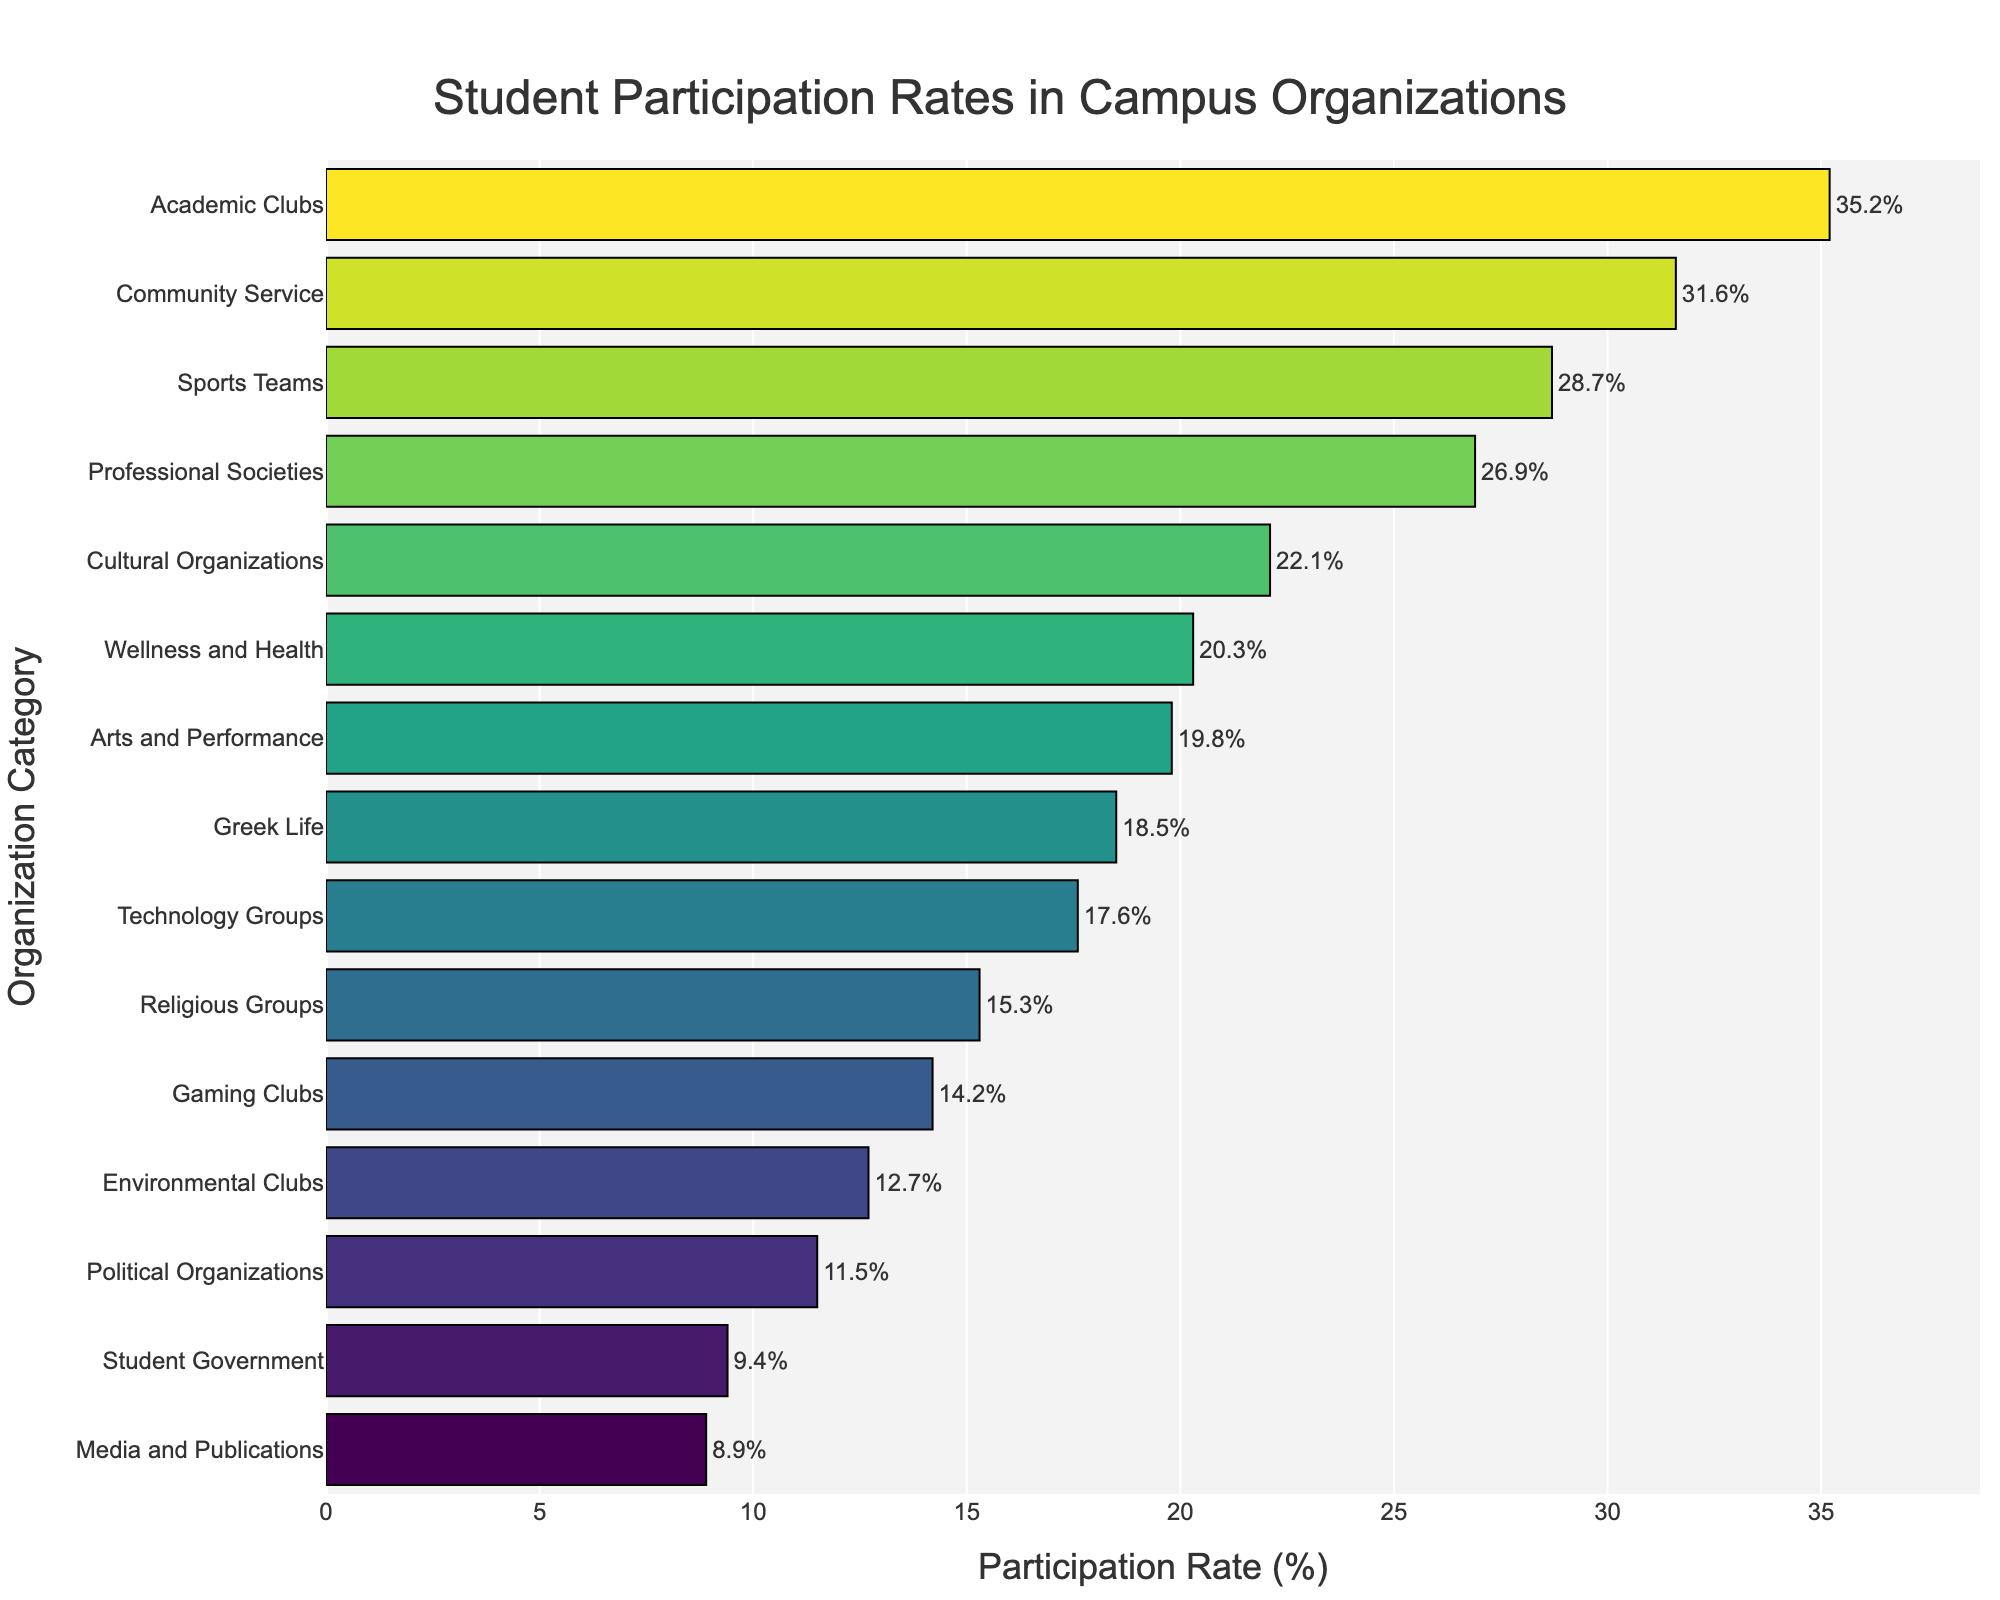Which category has the highest student participation rate? To find the category with the highest participation rate, we look for the longest bar in the chart. The "Academic Clubs" bar is the longest.
Answer: Academic Clubs Which category has the lowest student participation rate? To determine the category with the lowest participation rate, we look for the shortest bar in the chart. The "Media and Publications" bar is the shortest.
Answer: Media and Publications What are the participation rates for Community Service and Wellness and Health combined? First, find the participation rates for Community Service (31.6) and Wellness and Health (20.3). Add them together: 31.6 + 20.3 = 51.9.
Answer: 51.9% Which category has a higher participation rate: Sports Teams or Greek Life? Compare the lengths of the bars for Sports Teams and Greek Life. Sports Teams has a participation rate of 28.7, whereas Greek Life has a rate of 18.5.
Answer: Sports Teams What is the difference in participation rates between Professional Societies and Environmental Clubs? Find the participation rates for Professional Societies (26.9) and Environmental Clubs (12.7). Subtract the smaller rate from the larger: 26.9 - 12.7 = 14.2.
Answer: 14.2% Which categories have participation rates greater than 20%? Locate bars that extend beyond the 20% mark: Academic Clubs, Sports Teams, Community Service, Wellness and Health, and Arts and Performance.
Answer: Academic Clubs, Sports Teams, Community Service, Wellness and Health, Arts and Performance What is the average participation rate of the categories with rates over 25%? Find categories over 25%: Academic Clubs (35.2), Sports Teams (28.7), Community Service (31.6), and Professional Societies (26.9). Calculate the average: (35.2 + 28.7 + 31.6 + 26.9) / 4 = 30.6.
Answer: 30.6% Are there more categories with participation rates above or below 15%? Count categories above 15%: Academic Clubs, Sports Teams, Cultural Organizations, Greek Life, Community Service, Arts and Performance, Professional Societies, Technology Groups, Wellness and Health (9). Count categories below 15%: Political Organizations, Media and Publications, Gaming Clubs, Environmental Clubs, Religious Groups, Student Government, Technology Groups (6).
Answer: Above 15% What is the median participation rate of all categories? Sort the participation rates and find the middle value(s): 8.9, 9.4, 11.5, 12.7, 14.2, 15.3, 17.6, 18.5, 19.8, 20.3, 22.1, 26.9, 28.7, 31.6, 35.2. The median is the middle number: 18.5.
Answer: 18.5% Which category's participation rate is closest to the average rate across all categories? Calculate the total of all participation rates: 35.2 + 28.7 + 22.1 + 18.5 + 31.6 + 9.4 + 19.8 + 15.3 + 26.9 + 12.7 + 11.5 + 8.9 + 14.2 + 17.6 + 20.3 = 292.7. Divide by 15 (number of categories): 292.7 / 15 ≈ 19.51. Compare to individual rates, 19.8 is closest.
Answer: Arts and Performance 